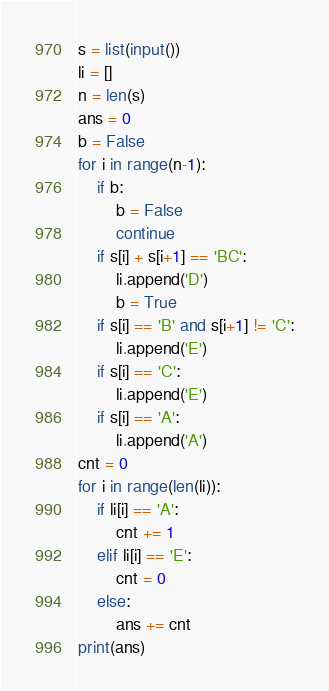<code> <loc_0><loc_0><loc_500><loc_500><_Python_>s = list(input())
li = []
n = len(s)
ans = 0
b = False
for i in range(n-1):
    if b:
        b = False
        continue
    if s[i] + s[i+1] == 'BC':
        li.append('D')
        b = True
    if s[i] == 'B' and s[i+1] != 'C':
        li.append('E')
    if s[i] == 'C':
        li.append('E')
    if s[i] == 'A':
        li.append('A')
cnt = 0
for i in range(len(li)):
    if li[i] == 'A':
        cnt += 1
    elif li[i] == 'E':
        cnt = 0
    else:
        ans += cnt
print(ans)</code> 